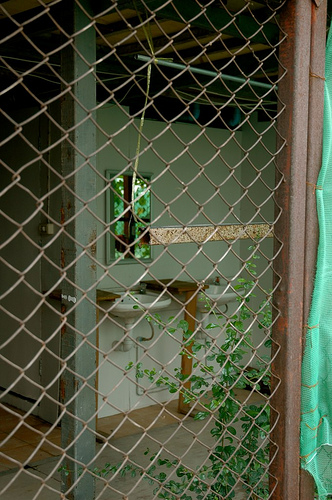<image>
Is the sink under the mirror? Yes. The sink is positioned underneath the mirror, with the mirror above it in the vertical space. 